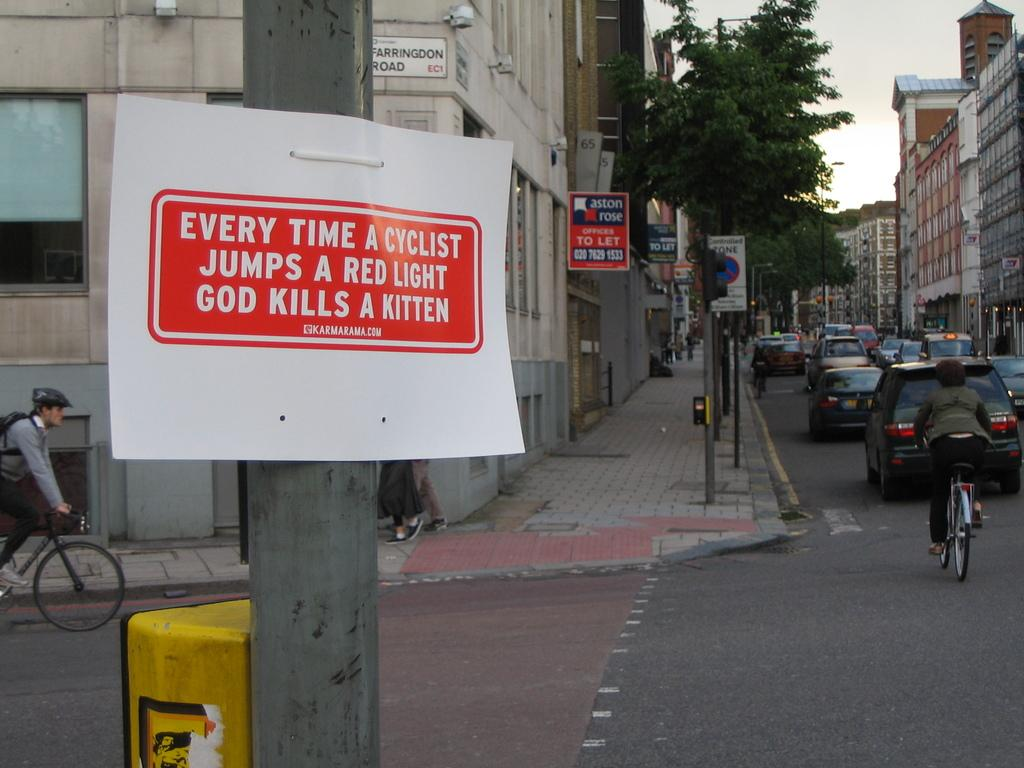<image>
Give a short and clear explanation of the subsequent image. A sign on a post says that every time a cyclist jumps a red light god kills a kitten. 